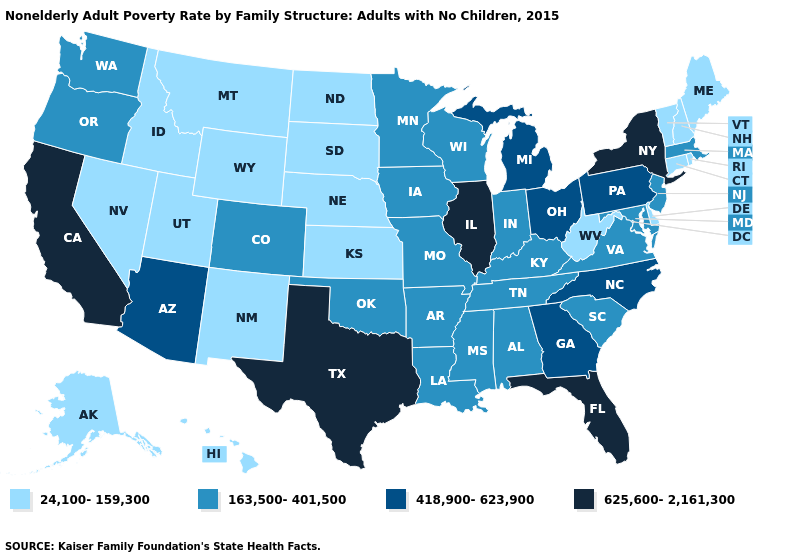What is the value of Massachusetts?
Answer briefly. 163,500-401,500. What is the value of Minnesota?
Keep it brief. 163,500-401,500. Among the states that border New Jersey , does Delaware have the lowest value?
Write a very short answer. Yes. What is the highest value in the South ?
Be succinct. 625,600-2,161,300. Among the states that border Nevada , which have the highest value?
Concise answer only. California. What is the value of Tennessee?
Concise answer only. 163,500-401,500. Does Massachusetts have the lowest value in the Northeast?
Write a very short answer. No. Does Maine have the same value as New York?
Be succinct. No. Name the states that have a value in the range 24,100-159,300?
Be succinct. Alaska, Connecticut, Delaware, Hawaii, Idaho, Kansas, Maine, Montana, Nebraska, Nevada, New Hampshire, New Mexico, North Dakota, Rhode Island, South Dakota, Utah, Vermont, West Virginia, Wyoming. Is the legend a continuous bar?
Write a very short answer. No. What is the value of North Carolina?
Give a very brief answer. 418,900-623,900. Name the states that have a value in the range 625,600-2,161,300?
Answer briefly. California, Florida, Illinois, New York, Texas. Name the states that have a value in the range 24,100-159,300?
Keep it brief. Alaska, Connecticut, Delaware, Hawaii, Idaho, Kansas, Maine, Montana, Nebraska, Nevada, New Hampshire, New Mexico, North Dakota, Rhode Island, South Dakota, Utah, Vermont, West Virginia, Wyoming. Does Washington have the same value as Texas?
Be succinct. No. What is the lowest value in the West?
Keep it brief. 24,100-159,300. 